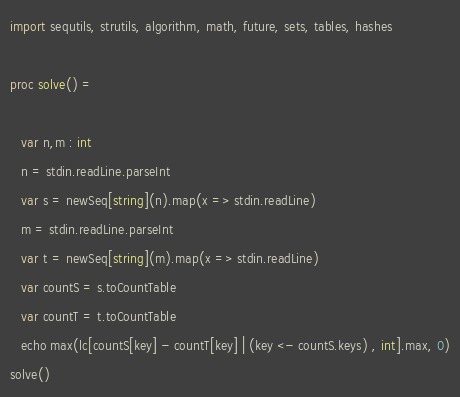<code> <loc_0><loc_0><loc_500><loc_500><_Nim_>import sequtils, strutils, algorithm, math, future, sets, tables, hashes

proc solve() =
   
   var n,m : int
   n = stdin.readLine.parseInt
   var s = newSeq[string](n).map(x => stdin.readLine)
   m = stdin.readLine.parseInt
   var t = newSeq[string](m).map(x => stdin.readLine)
   var countS = s.toCountTable
   var countT = t.toCountTable
   echo max(lc[countS[key] - countT[key] | (key <- countS.keys) , int].max, 0)
solve()</code> 